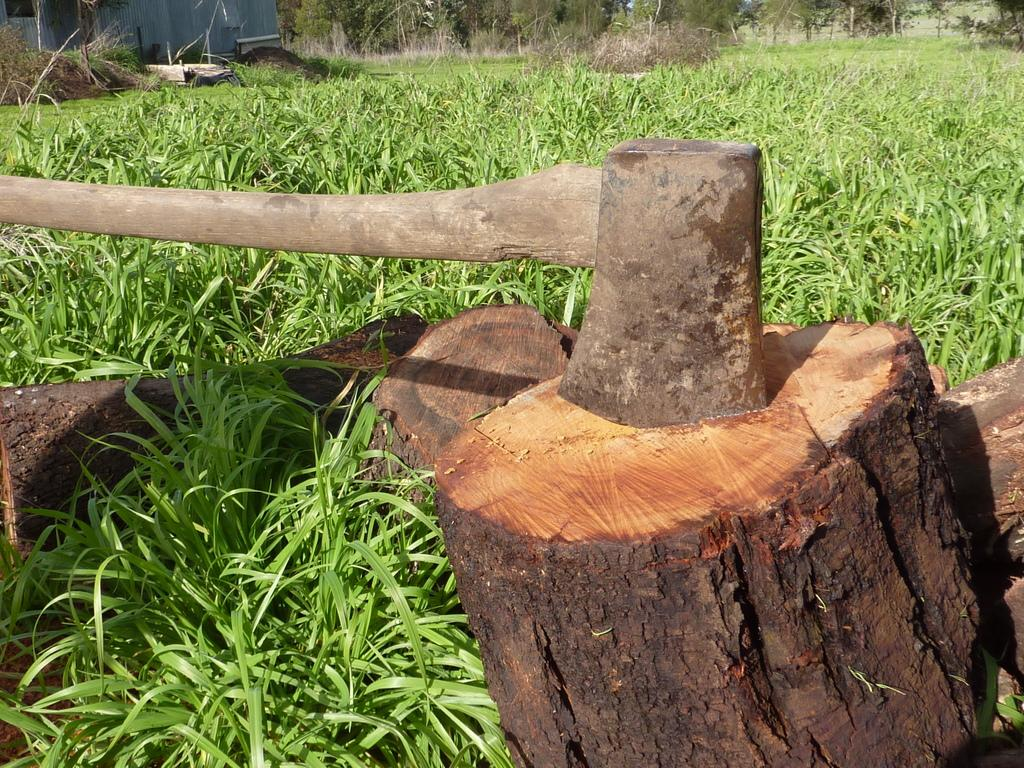What is the main subject of the image? The main subject of the image is tree bark. What object is present in the image that might be used to cut the tree bark? There is an axe in the image. What type of vegetation is visible at the bottom of the image? Grass is visible at the bottom of the image. What can be seen in the background of the image? There are trees in the background of the image. What type of oatmeal is being served in the image? There is no oatmeal present in the image. Are there any police officers visible in the image? There are no police officers present in the image. 